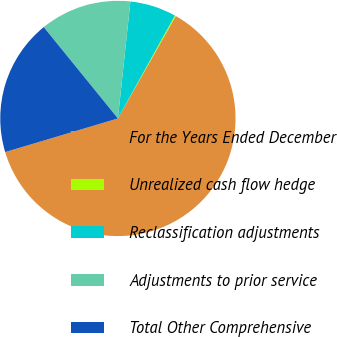<chart> <loc_0><loc_0><loc_500><loc_500><pie_chart><fcel>For the Years Ended December<fcel>Unrealized cash flow hedge<fcel>Reclassification adjustments<fcel>Adjustments to prior service<fcel>Total Other Comprehensive<nl><fcel>62.2%<fcel>0.14%<fcel>6.35%<fcel>12.55%<fcel>18.76%<nl></chart> 